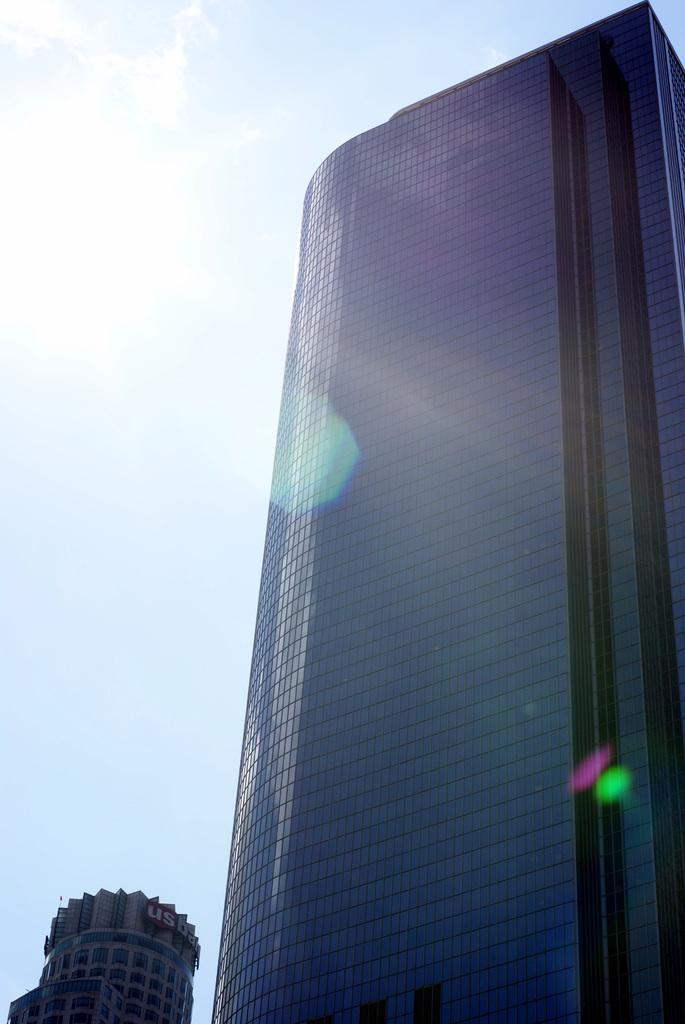What type of structures can be seen in the image? There are buildings in the image. What is the condition of the sky in the image? The sky is clear in the image. Can the sun be seen in the image? Yes, the sun is visible in the image. What type of cave can be seen in the image? There is no cave present in the image; it features buildings, a clear sky, and the sun. What channel is being broadcasted in the image? There is no television or channel present in the image. 